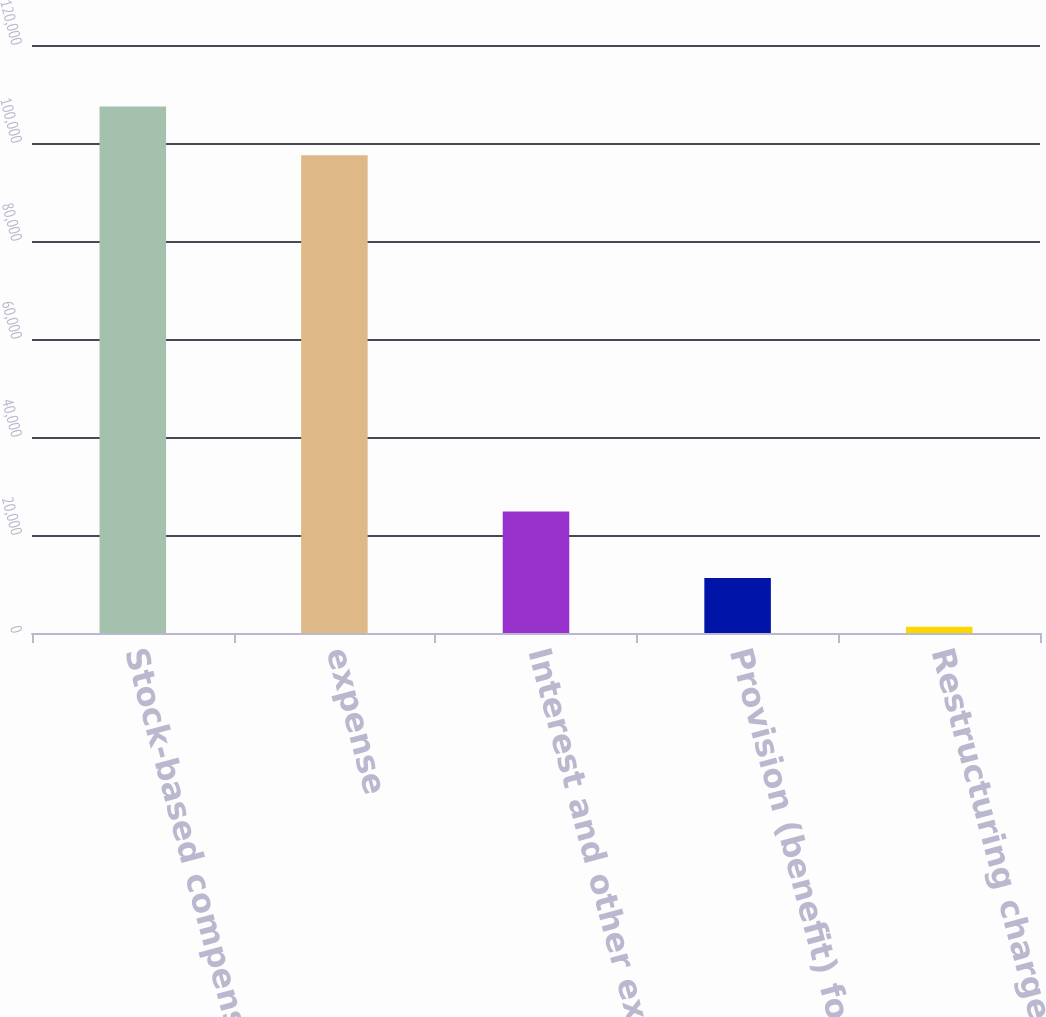<chart> <loc_0><loc_0><loc_500><loc_500><bar_chart><fcel>Stock-based compensation<fcel>expense<fcel>Interest and other expense net<fcel>Provision (benefit) for income<fcel>Restructuring charges and<nl><fcel>107461<fcel>97492<fcel>24810<fcel>11238<fcel>1269<nl></chart> 